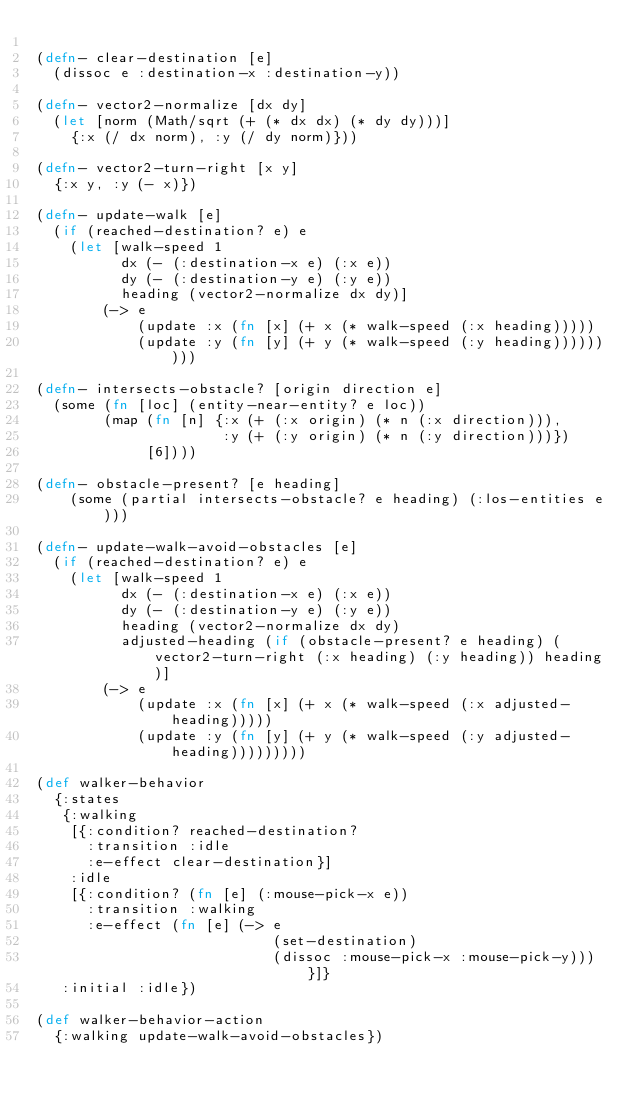Convert code to text. <code><loc_0><loc_0><loc_500><loc_500><_Clojure_>
(defn- clear-destination [e]
  (dissoc e :destination-x :destination-y))

(defn- vector2-normalize [dx dy]
  (let [norm (Math/sqrt (+ (* dx dx) (* dy dy)))]
    {:x (/ dx norm), :y (/ dy norm)}))

(defn- vector2-turn-right [x y]
  {:x y, :y (- x)})

(defn- update-walk [e]
  (if (reached-destination? e) e
    (let [walk-speed 1
          dx (- (:destination-x e) (:x e))
          dy (- (:destination-y e) (:y e))
          heading (vector2-normalize dx dy)]
        (-> e
            (update :x (fn [x] (+ x (* walk-speed (:x heading)))))
            (update :y (fn [y] (+ y (* walk-speed (:y heading)))))))))

(defn- intersects-obstacle? [origin direction e]
  (some (fn [loc] (entity-near-entity? e loc))
        (map (fn [n] {:x (+ (:x origin) (* n (:x direction))),
                      :y (+ (:y origin) (* n (:y direction)))})
             [6])))

(defn- obstacle-present? [e heading]
    (some (partial intersects-obstacle? e heading) (:los-entities e)))

(defn- update-walk-avoid-obstacles [e]
  (if (reached-destination? e) e
    (let [walk-speed 1
          dx (- (:destination-x e) (:x e))
          dy (- (:destination-y e) (:y e))
          heading (vector2-normalize dx dy)
          adjusted-heading (if (obstacle-present? e heading) (vector2-turn-right (:x heading) (:y heading)) heading)]
        (-> e
            (update :x (fn [x] (+ x (* walk-speed (:x adjusted-heading)))))
            (update :y (fn [y] (+ y (* walk-speed (:y adjusted-heading)))))))))

(def walker-behavior
  {:states
   {:walking
    [{:condition? reached-destination?
      :transition :idle
      :e-effect clear-destination}]
    :idle
    [{:condition? (fn [e] (:mouse-pick-x e))
      :transition :walking
      :e-effect (fn [e] (-> e
                            (set-destination)
                            (dissoc :mouse-pick-x :mouse-pick-y)))}]}
   :initial :idle})

(def walker-behavior-action
  {:walking update-walk-avoid-obstacles})


</code> 